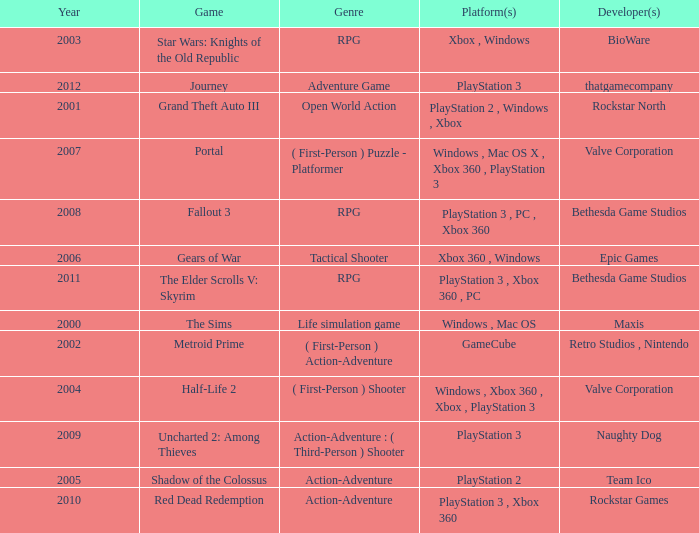What game was in 2005? Shadow of the Colossus. 